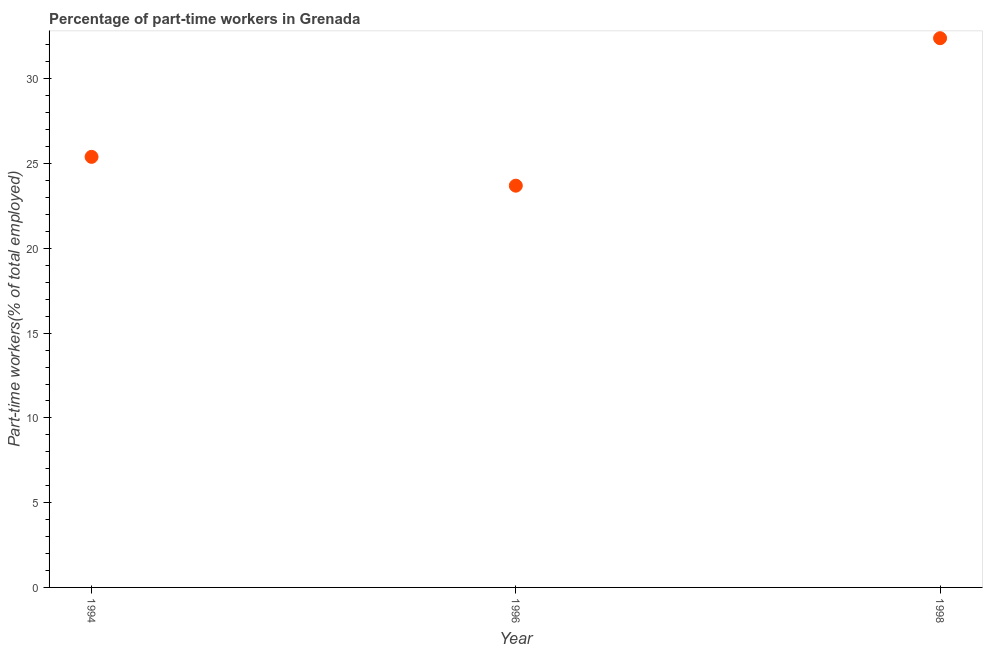What is the percentage of part-time workers in 1996?
Offer a very short reply. 23.7. Across all years, what is the maximum percentage of part-time workers?
Offer a very short reply. 32.4. Across all years, what is the minimum percentage of part-time workers?
Give a very brief answer. 23.7. In which year was the percentage of part-time workers minimum?
Provide a short and direct response. 1996. What is the sum of the percentage of part-time workers?
Give a very brief answer. 81.5. What is the difference between the percentage of part-time workers in 1994 and 1998?
Ensure brevity in your answer.  -7. What is the average percentage of part-time workers per year?
Ensure brevity in your answer.  27.17. What is the median percentage of part-time workers?
Your response must be concise. 25.4. Do a majority of the years between 1996 and 1998 (inclusive) have percentage of part-time workers greater than 20 %?
Offer a terse response. Yes. What is the ratio of the percentage of part-time workers in 1994 to that in 1996?
Make the answer very short. 1.07. Is the percentage of part-time workers in 1994 less than that in 1996?
Offer a very short reply. No. What is the difference between the highest and the second highest percentage of part-time workers?
Your answer should be compact. 7. Is the sum of the percentage of part-time workers in 1994 and 1996 greater than the maximum percentage of part-time workers across all years?
Give a very brief answer. Yes. What is the difference between the highest and the lowest percentage of part-time workers?
Ensure brevity in your answer.  8.7. In how many years, is the percentage of part-time workers greater than the average percentage of part-time workers taken over all years?
Your response must be concise. 1. Does the percentage of part-time workers monotonically increase over the years?
Offer a very short reply. No. Does the graph contain grids?
Make the answer very short. No. What is the title of the graph?
Your answer should be compact. Percentage of part-time workers in Grenada. What is the label or title of the Y-axis?
Keep it short and to the point. Part-time workers(% of total employed). What is the Part-time workers(% of total employed) in 1994?
Your answer should be very brief. 25.4. What is the Part-time workers(% of total employed) in 1996?
Keep it short and to the point. 23.7. What is the Part-time workers(% of total employed) in 1998?
Your response must be concise. 32.4. What is the difference between the Part-time workers(% of total employed) in 1994 and 1996?
Provide a succinct answer. 1.7. What is the ratio of the Part-time workers(% of total employed) in 1994 to that in 1996?
Provide a succinct answer. 1.07. What is the ratio of the Part-time workers(% of total employed) in 1994 to that in 1998?
Make the answer very short. 0.78. What is the ratio of the Part-time workers(% of total employed) in 1996 to that in 1998?
Your answer should be very brief. 0.73. 